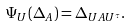Convert formula to latex. <formula><loc_0><loc_0><loc_500><loc_500>\Psi _ { U } ( \Delta _ { A } ) = \Delta _ { U A U ^ { \tau } } .</formula> 